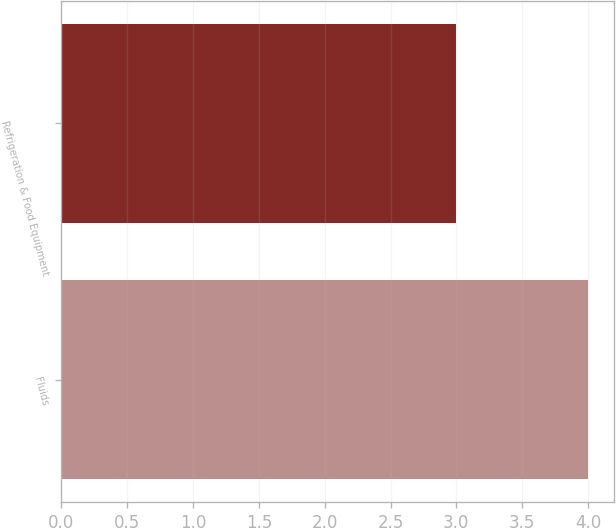<chart> <loc_0><loc_0><loc_500><loc_500><bar_chart><fcel>Fluids<fcel>Refrigeration & Food Equipment<nl><fcel>4<fcel>3<nl></chart> 